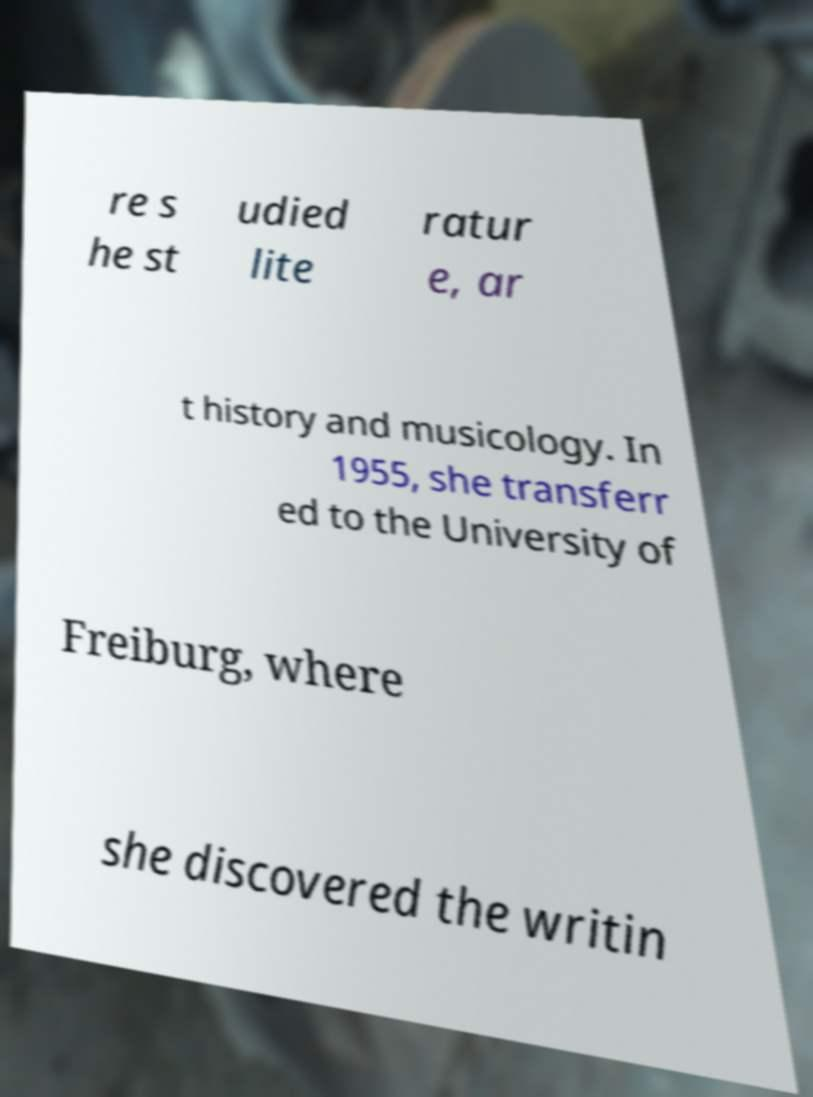There's text embedded in this image that I need extracted. Can you transcribe it verbatim? re s he st udied lite ratur e, ar t history and musicology. In 1955, she transferr ed to the University of Freiburg, where she discovered the writin 